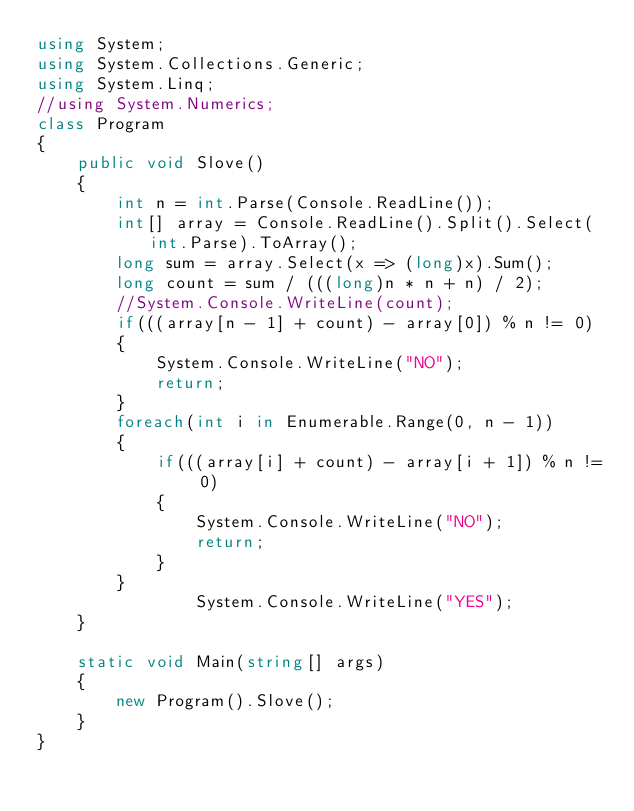Convert code to text. <code><loc_0><loc_0><loc_500><loc_500><_C#_>using System;
using System.Collections.Generic;
using System.Linq;
//using System.Numerics;
class Program
{       
    public void Slove()
    {
        int n = int.Parse(Console.ReadLine());
        int[] array = Console.ReadLine().Split().Select(int.Parse).ToArray();
        long sum = array.Select(x => (long)x).Sum();
        long count = sum / (((long)n * n + n) / 2); 
        //System.Console.WriteLine(count);
        if(((array[n - 1] + count) - array[0]) % n != 0)
        {
            System.Console.WriteLine("NO");
            return;
        }
        foreach(int i in Enumerable.Range(0, n - 1))
        {
            if(((array[i] + count) - array[i + 1]) % n != 0)
            {
                System.Console.WriteLine("NO");
                return;
            }
        }
                System.Console.WriteLine("YES");
    }
    
    static void Main(string[] args)
    {
        new Program().Slove();
    }
}
</code> 